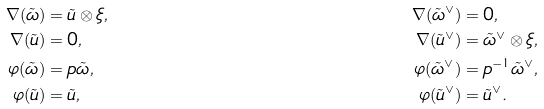<formula> <loc_0><loc_0><loc_500><loc_500>\nabla ( \tilde { \omega } ) & = \tilde { u } \otimes \xi , & \nabla ( \tilde { \omega } ^ { \vee } ) & = 0 , \\ \nabla ( \tilde { u } ) & = 0 , & \nabla ( \tilde { u } ^ { \vee } ) & = \tilde { \omega } ^ { \vee } \otimes \xi , \\ \varphi ( \tilde { \omega } ) & = p \tilde { \omega } , & \varphi ( \tilde { \omega } ^ { \vee } ) & = p ^ { - 1 } \tilde { \omega } ^ { \vee } , \\ \varphi ( \tilde { u } ) & = \tilde { u } , & \varphi ( \tilde { u } ^ { \vee } ) & = \tilde { u } ^ { \vee } .</formula> 